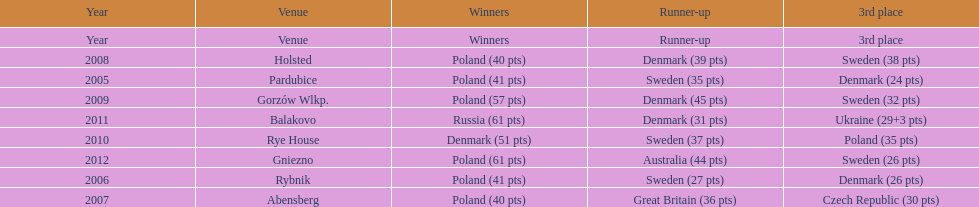What was the last year 3rd place finished with less than 25 points? 2005. 